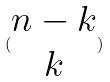<formula> <loc_0><loc_0><loc_500><loc_500>( \begin{matrix} n - k \\ k \end{matrix} )</formula> 